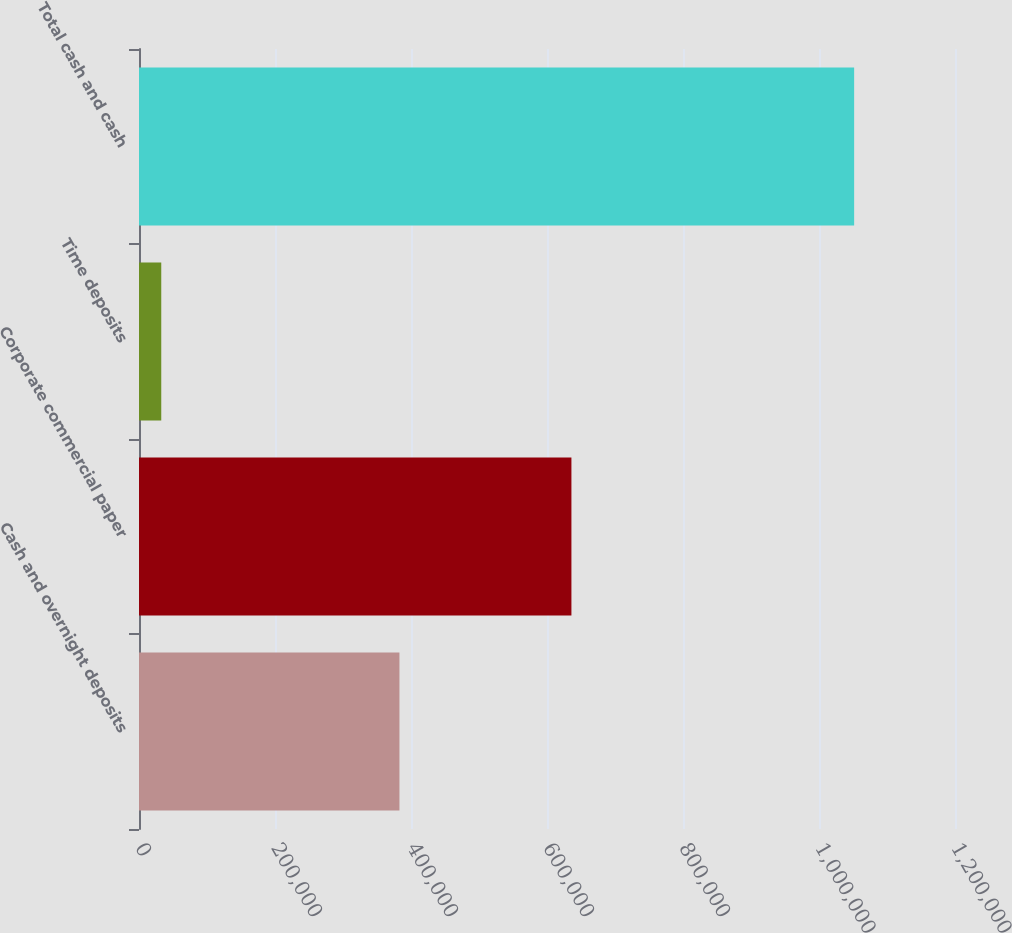Convert chart. <chart><loc_0><loc_0><loc_500><loc_500><bar_chart><fcel>Cash and overnight deposits<fcel>Corporate commercial paper<fcel>Time deposits<fcel>Total cash and cash<nl><fcel>383021<fcel>635919<fcel>32733<fcel>1.05167e+06<nl></chart> 